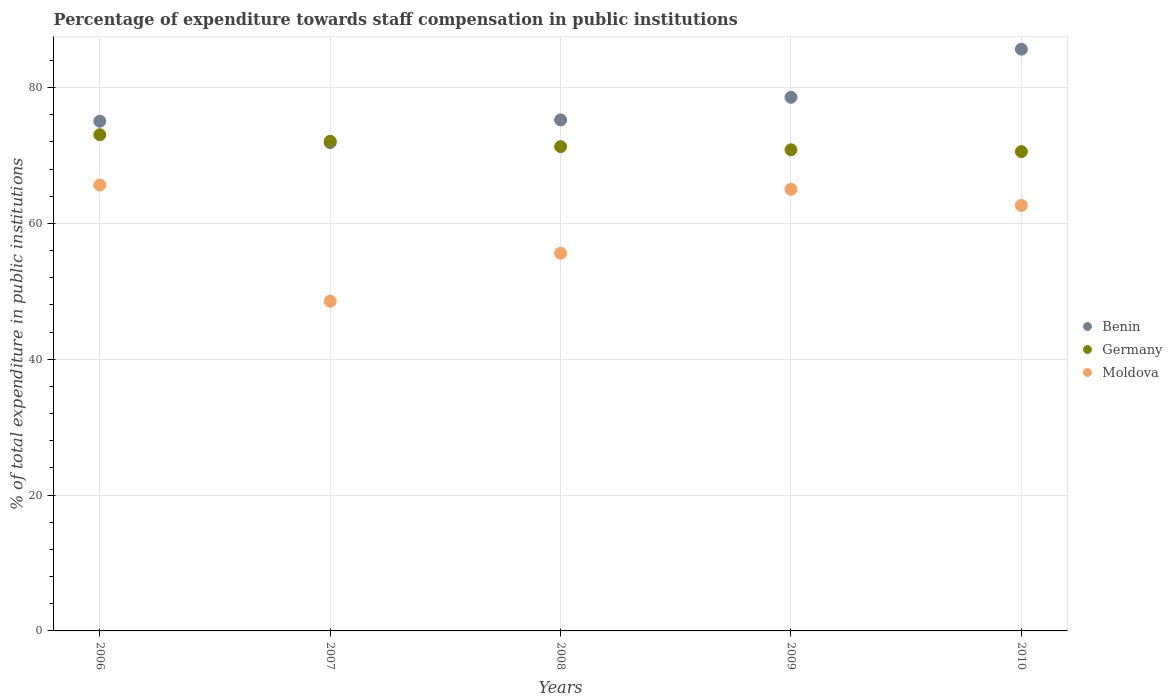How many different coloured dotlines are there?
Offer a terse response. 3. Is the number of dotlines equal to the number of legend labels?
Make the answer very short. Yes. What is the percentage of expenditure towards staff compensation in Moldova in 2006?
Your answer should be very brief. 65.65. Across all years, what is the maximum percentage of expenditure towards staff compensation in Germany?
Offer a very short reply. 73.06. Across all years, what is the minimum percentage of expenditure towards staff compensation in Germany?
Offer a very short reply. 70.57. In which year was the percentage of expenditure towards staff compensation in Germany maximum?
Make the answer very short. 2006. In which year was the percentage of expenditure towards staff compensation in Moldova minimum?
Offer a very short reply. 2007. What is the total percentage of expenditure towards staff compensation in Benin in the graph?
Your answer should be very brief. 386.41. What is the difference between the percentage of expenditure towards staff compensation in Benin in 2007 and that in 2010?
Provide a short and direct response. -13.76. What is the difference between the percentage of expenditure towards staff compensation in Germany in 2006 and the percentage of expenditure towards staff compensation in Benin in 2010?
Provide a short and direct response. -12.6. What is the average percentage of expenditure towards staff compensation in Germany per year?
Offer a terse response. 71.57. In the year 2008, what is the difference between the percentage of expenditure towards staff compensation in Benin and percentage of expenditure towards staff compensation in Germany?
Provide a succinct answer. 3.93. In how many years, is the percentage of expenditure towards staff compensation in Benin greater than 24 %?
Provide a succinct answer. 5. What is the ratio of the percentage of expenditure towards staff compensation in Benin in 2006 to that in 2008?
Provide a short and direct response. 1. What is the difference between the highest and the second highest percentage of expenditure towards staff compensation in Benin?
Your response must be concise. 7.08. What is the difference between the highest and the lowest percentage of expenditure towards staff compensation in Germany?
Your answer should be compact. 2.49. Is the sum of the percentage of expenditure towards staff compensation in Moldova in 2006 and 2010 greater than the maximum percentage of expenditure towards staff compensation in Benin across all years?
Offer a terse response. Yes. Is it the case that in every year, the sum of the percentage of expenditure towards staff compensation in Benin and percentage of expenditure towards staff compensation in Moldova  is greater than the percentage of expenditure towards staff compensation in Germany?
Provide a succinct answer. Yes. Is the percentage of expenditure towards staff compensation in Moldova strictly less than the percentage of expenditure towards staff compensation in Germany over the years?
Give a very brief answer. Yes. How many dotlines are there?
Ensure brevity in your answer.  3. What is the difference between two consecutive major ticks on the Y-axis?
Your answer should be compact. 20. Are the values on the major ticks of Y-axis written in scientific E-notation?
Your response must be concise. No. Does the graph contain any zero values?
Your response must be concise. No. Does the graph contain grids?
Give a very brief answer. Yes. How many legend labels are there?
Provide a short and direct response. 3. How are the legend labels stacked?
Your response must be concise. Vertical. What is the title of the graph?
Your answer should be very brief. Percentage of expenditure towards staff compensation in public institutions. Does "Kyrgyz Republic" appear as one of the legend labels in the graph?
Provide a short and direct response. No. What is the label or title of the X-axis?
Your response must be concise. Years. What is the label or title of the Y-axis?
Offer a very short reply. % of total expenditure in public institutions. What is the % of total expenditure in public institutions of Benin in 2006?
Offer a very short reply. 75.05. What is the % of total expenditure in public institutions in Germany in 2006?
Provide a succinct answer. 73.06. What is the % of total expenditure in public institutions of Moldova in 2006?
Provide a short and direct response. 65.65. What is the % of total expenditure in public institutions in Benin in 2007?
Your response must be concise. 71.89. What is the % of total expenditure in public institutions in Germany in 2007?
Provide a short and direct response. 72.1. What is the % of total expenditure in public institutions of Moldova in 2007?
Offer a terse response. 48.54. What is the % of total expenditure in public institutions in Benin in 2008?
Keep it short and to the point. 75.24. What is the % of total expenditure in public institutions of Germany in 2008?
Offer a terse response. 71.3. What is the % of total expenditure in public institutions in Moldova in 2008?
Ensure brevity in your answer.  55.61. What is the % of total expenditure in public institutions in Benin in 2009?
Your response must be concise. 78.57. What is the % of total expenditure in public institutions in Germany in 2009?
Your answer should be compact. 70.84. What is the % of total expenditure in public institutions in Moldova in 2009?
Your answer should be very brief. 65.02. What is the % of total expenditure in public institutions in Benin in 2010?
Provide a succinct answer. 85.65. What is the % of total expenditure in public institutions of Germany in 2010?
Provide a short and direct response. 70.57. What is the % of total expenditure in public institutions of Moldova in 2010?
Offer a very short reply. 62.65. Across all years, what is the maximum % of total expenditure in public institutions in Benin?
Provide a short and direct response. 85.65. Across all years, what is the maximum % of total expenditure in public institutions of Germany?
Your answer should be very brief. 73.06. Across all years, what is the maximum % of total expenditure in public institutions in Moldova?
Provide a succinct answer. 65.65. Across all years, what is the minimum % of total expenditure in public institutions of Benin?
Your response must be concise. 71.89. Across all years, what is the minimum % of total expenditure in public institutions of Germany?
Make the answer very short. 70.57. Across all years, what is the minimum % of total expenditure in public institutions of Moldova?
Ensure brevity in your answer.  48.54. What is the total % of total expenditure in public institutions of Benin in the graph?
Your answer should be compact. 386.41. What is the total % of total expenditure in public institutions of Germany in the graph?
Offer a very short reply. 357.87. What is the total % of total expenditure in public institutions in Moldova in the graph?
Your answer should be very brief. 297.47. What is the difference between the % of total expenditure in public institutions in Benin in 2006 and that in 2007?
Provide a short and direct response. 3.15. What is the difference between the % of total expenditure in public institutions in Germany in 2006 and that in 2007?
Your answer should be compact. 0.96. What is the difference between the % of total expenditure in public institutions of Moldova in 2006 and that in 2007?
Provide a short and direct response. 17.11. What is the difference between the % of total expenditure in public institutions of Benin in 2006 and that in 2008?
Ensure brevity in your answer.  -0.19. What is the difference between the % of total expenditure in public institutions of Germany in 2006 and that in 2008?
Your answer should be compact. 1.75. What is the difference between the % of total expenditure in public institutions in Moldova in 2006 and that in 2008?
Provide a succinct answer. 10.04. What is the difference between the % of total expenditure in public institutions of Benin in 2006 and that in 2009?
Offer a terse response. -3.52. What is the difference between the % of total expenditure in public institutions of Germany in 2006 and that in 2009?
Offer a terse response. 2.22. What is the difference between the % of total expenditure in public institutions in Moldova in 2006 and that in 2009?
Offer a very short reply. 0.63. What is the difference between the % of total expenditure in public institutions in Benin in 2006 and that in 2010?
Provide a short and direct response. -10.61. What is the difference between the % of total expenditure in public institutions of Germany in 2006 and that in 2010?
Your answer should be compact. 2.49. What is the difference between the % of total expenditure in public institutions in Moldova in 2006 and that in 2010?
Your answer should be very brief. 3. What is the difference between the % of total expenditure in public institutions in Benin in 2007 and that in 2008?
Keep it short and to the point. -3.34. What is the difference between the % of total expenditure in public institutions in Germany in 2007 and that in 2008?
Provide a succinct answer. 0.79. What is the difference between the % of total expenditure in public institutions in Moldova in 2007 and that in 2008?
Offer a terse response. -7.07. What is the difference between the % of total expenditure in public institutions of Benin in 2007 and that in 2009?
Your answer should be very brief. -6.68. What is the difference between the % of total expenditure in public institutions of Germany in 2007 and that in 2009?
Your answer should be very brief. 1.25. What is the difference between the % of total expenditure in public institutions in Moldova in 2007 and that in 2009?
Keep it short and to the point. -16.48. What is the difference between the % of total expenditure in public institutions of Benin in 2007 and that in 2010?
Provide a succinct answer. -13.76. What is the difference between the % of total expenditure in public institutions in Germany in 2007 and that in 2010?
Your response must be concise. 1.53. What is the difference between the % of total expenditure in public institutions in Moldova in 2007 and that in 2010?
Provide a succinct answer. -14.11. What is the difference between the % of total expenditure in public institutions of Benin in 2008 and that in 2009?
Provide a short and direct response. -3.34. What is the difference between the % of total expenditure in public institutions of Germany in 2008 and that in 2009?
Make the answer very short. 0.46. What is the difference between the % of total expenditure in public institutions of Moldova in 2008 and that in 2009?
Provide a succinct answer. -9.41. What is the difference between the % of total expenditure in public institutions of Benin in 2008 and that in 2010?
Your answer should be compact. -10.42. What is the difference between the % of total expenditure in public institutions in Germany in 2008 and that in 2010?
Ensure brevity in your answer.  0.73. What is the difference between the % of total expenditure in public institutions of Moldova in 2008 and that in 2010?
Ensure brevity in your answer.  -7.04. What is the difference between the % of total expenditure in public institutions in Benin in 2009 and that in 2010?
Ensure brevity in your answer.  -7.08. What is the difference between the % of total expenditure in public institutions in Germany in 2009 and that in 2010?
Give a very brief answer. 0.27. What is the difference between the % of total expenditure in public institutions in Moldova in 2009 and that in 2010?
Your answer should be very brief. 2.37. What is the difference between the % of total expenditure in public institutions of Benin in 2006 and the % of total expenditure in public institutions of Germany in 2007?
Give a very brief answer. 2.95. What is the difference between the % of total expenditure in public institutions in Benin in 2006 and the % of total expenditure in public institutions in Moldova in 2007?
Give a very brief answer. 26.51. What is the difference between the % of total expenditure in public institutions in Germany in 2006 and the % of total expenditure in public institutions in Moldova in 2007?
Your response must be concise. 24.52. What is the difference between the % of total expenditure in public institutions in Benin in 2006 and the % of total expenditure in public institutions in Germany in 2008?
Give a very brief answer. 3.74. What is the difference between the % of total expenditure in public institutions of Benin in 2006 and the % of total expenditure in public institutions of Moldova in 2008?
Make the answer very short. 19.44. What is the difference between the % of total expenditure in public institutions in Germany in 2006 and the % of total expenditure in public institutions in Moldova in 2008?
Your response must be concise. 17.45. What is the difference between the % of total expenditure in public institutions of Benin in 2006 and the % of total expenditure in public institutions of Germany in 2009?
Your answer should be compact. 4.21. What is the difference between the % of total expenditure in public institutions in Benin in 2006 and the % of total expenditure in public institutions in Moldova in 2009?
Ensure brevity in your answer.  10.03. What is the difference between the % of total expenditure in public institutions in Germany in 2006 and the % of total expenditure in public institutions in Moldova in 2009?
Your answer should be very brief. 8.04. What is the difference between the % of total expenditure in public institutions of Benin in 2006 and the % of total expenditure in public institutions of Germany in 2010?
Give a very brief answer. 4.48. What is the difference between the % of total expenditure in public institutions in Benin in 2006 and the % of total expenditure in public institutions in Moldova in 2010?
Ensure brevity in your answer.  12.4. What is the difference between the % of total expenditure in public institutions of Germany in 2006 and the % of total expenditure in public institutions of Moldova in 2010?
Keep it short and to the point. 10.41. What is the difference between the % of total expenditure in public institutions of Benin in 2007 and the % of total expenditure in public institutions of Germany in 2008?
Your response must be concise. 0.59. What is the difference between the % of total expenditure in public institutions of Benin in 2007 and the % of total expenditure in public institutions of Moldova in 2008?
Offer a very short reply. 16.28. What is the difference between the % of total expenditure in public institutions in Germany in 2007 and the % of total expenditure in public institutions in Moldova in 2008?
Ensure brevity in your answer.  16.49. What is the difference between the % of total expenditure in public institutions in Benin in 2007 and the % of total expenditure in public institutions in Germany in 2009?
Your answer should be very brief. 1.05. What is the difference between the % of total expenditure in public institutions in Benin in 2007 and the % of total expenditure in public institutions in Moldova in 2009?
Make the answer very short. 6.87. What is the difference between the % of total expenditure in public institutions in Germany in 2007 and the % of total expenditure in public institutions in Moldova in 2009?
Provide a succinct answer. 7.08. What is the difference between the % of total expenditure in public institutions of Benin in 2007 and the % of total expenditure in public institutions of Germany in 2010?
Offer a very short reply. 1.32. What is the difference between the % of total expenditure in public institutions in Benin in 2007 and the % of total expenditure in public institutions in Moldova in 2010?
Ensure brevity in your answer.  9.25. What is the difference between the % of total expenditure in public institutions in Germany in 2007 and the % of total expenditure in public institutions in Moldova in 2010?
Your answer should be very brief. 9.45. What is the difference between the % of total expenditure in public institutions of Benin in 2008 and the % of total expenditure in public institutions of Germany in 2009?
Offer a terse response. 4.39. What is the difference between the % of total expenditure in public institutions of Benin in 2008 and the % of total expenditure in public institutions of Moldova in 2009?
Keep it short and to the point. 10.21. What is the difference between the % of total expenditure in public institutions in Germany in 2008 and the % of total expenditure in public institutions in Moldova in 2009?
Offer a very short reply. 6.28. What is the difference between the % of total expenditure in public institutions of Benin in 2008 and the % of total expenditure in public institutions of Germany in 2010?
Provide a short and direct response. 4.67. What is the difference between the % of total expenditure in public institutions in Benin in 2008 and the % of total expenditure in public institutions in Moldova in 2010?
Provide a succinct answer. 12.59. What is the difference between the % of total expenditure in public institutions in Germany in 2008 and the % of total expenditure in public institutions in Moldova in 2010?
Ensure brevity in your answer.  8.66. What is the difference between the % of total expenditure in public institutions in Benin in 2009 and the % of total expenditure in public institutions in Germany in 2010?
Make the answer very short. 8. What is the difference between the % of total expenditure in public institutions in Benin in 2009 and the % of total expenditure in public institutions in Moldova in 2010?
Your response must be concise. 15.93. What is the difference between the % of total expenditure in public institutions in Germany in 2009 and the % of total expenditure in public institutions in Moldova in 2010?
Your answer should be compact. 8.2. What is the average % of total expenditure in public institutions in Benin per year?
Your answer should be very brief. 77.28. What is the average % of total expenditure in public institutions of Germany per year?
Provide a short and direct response. 71.57. What is the average % of total expenditure in public institutions of Moldova per year?
Your answer should be compact. 59.49. In the year 2006, what is the difference between the % of total expenditure in public institutions in Benin and % of total expenditure in public institutions in Germany?
Give a very brief answer. 1.99. In the year 2006, what is the difference between the % of total expenditure in public institutions of Benin and % of total expenditure in public institutions of Moldova?
Give a very brief answer. 9.4. In the year 2006, what is the difference between the % of total expenditure in public institutions in Germany and % of total expenditure in public institutions in Moldova?
Provide a succinct answer. 7.41. In the year 2007, what is the difference between the % of total expenditure in public institutions in Benin and % of total expenditure in public institutions in Germany?
Give a very brief answer. -0.2. In the year 2007, what is the difference between the % of total expenditure in public institutions in Benin and % of total expenditure in public institutions in Moldova?
Provide a short and direct response. 23.35. In the year 2007, what is the difference between the % of total expenditure in public institutions of Germany and % of total expenditure in public institutions of Moldova?
Provide a short and direct response. 23.56. In the year 2008, what is the difference between the % of total expenditure in public institutions of Benin and % of total expenditure in public institutions of Germany?
Keep it short and to the point. 3.93. In the year 2008, what is the difference between the % of total expenditure in public institutions in Benin and % of total expenditure in public institutions in Moldova?
Your answer should be compact. 19.63. In the year 2008, what is the difference between the % of total expenditure in public institutions in Germany and % of total expenditure in public institutions in Moldova?
Offer a terse response. 15.7. In the year 2009, what is the difference between the % of total expenditure in public institutions in Benin and % of total expenditure in public institutions in Germany?
Keep it short and to the point. 7.73. In the year 2009, what is the difference between the % of total expenditure in public institutions of Benin and % of total expenditure in public institutions of Moldova?
Provide a succinct answer. 13.55. In the year 2009, what is the difference between the % of total expenditure in public institutions in Germany and % of total expenditure in public institutions in Moldova?
Ensure brevity in your answer.  5.82. In the year 2010, what is the difference between the % of total expenditure in public institutions in Benin and % of total expenditure in public institutions in Germany?
Provide a succinct answer. 15.08. In the year 2010, what is the difference between the % of total expenditure in public institutions of Benin and % of total expenditure in public institutions of Moldova?
Ensure brevity in your answer.  23.01. In the year 2010, what is the difference between the % of total expenditure in public institutions in Germany and % of total expenditure in public institutions in Moldova?
Your answer should be very brief. 7.92. What is the ratio of the % of total expenditure in public institutions of Benin in 2006 to that in 2007?
Ensure brevity in your answer.  1.04. What is the ratio of the % of total expenditure in public institutions in Germany in 2006 to that in 2007?
Your answer should be very brief. 1.01. What is the ratio of the % of total expenditure in public institutions in Moldova in 2006 to that in 2007?
Your response must be concise. 1.35. What is the ratio of the % of total expenditure in public institutions in Benin in 2006 to that in 2008?
Give a very brief answer. 1. What is the ratio of the % of total expenditure in public institutions of Germany in 2006 to that in 2008?
Offer a terse response. 1.02. What is the ratio of the % of total expenditure in public institutions of Moldova in 2006 to that in 2008?
Provide a succinct answer. 1.18. What is the ratio of the % of total expenditure in public institutions of Benin in 2006 to that in 2009?
Offer a terse response. 0.96. What is the ratio of the % of total expenditure in public institutions of Germany in 2006 to that in 2009?
Provide a short and direct response. 1.03. What is the ratio of the % of total expenditure in public institutions in Moldova in 2006 to that in 2009?
Your answer should be very brief. 1.01. What is the ratio of the % of total expenditure in public institutions of Benin in 2006 to that in 2010?
Provide a short and direct response. 0.88. What is the ratio of the % of total expenditure in public institutions in Germany in 2006 to that in 2010?
Provide a short and direct response. 1.04. What is the ratio of the % of total expenditure in public institutions in Moldova in 2006 to that in 2010?
Provide a succinct answer. 1.05. What is the ratio of the % of total expenditure in public institutions of Benin in 2007 to that in 2008?
Offer a terse response. 0.96. What is the ratio of the % of total expenditure in public institutions of Germany in 2007 to that in 2008?
Provide a short and direct response. 1.01. What is the ratio of the % of total expenditure in public institutions of Moldova in 2007 to that in 2008?
Ensure brevity in your answer.  0.87. What is the ratio of the % of total expenditure in public institutions in Benin in 2007 to that in 2009?
Your response must be concise. 0.92. What is the ratio of the % of total expenditure in public institutions in Germany in 2007 to that in 2009?
Offer a very short reply. 1.02. What is the ratio of the % of total expenditure in public institutions in Moldova in 2007 to that in 2009?
Make the answer very short. 0.75. What is the ratio of the % of total expenditure in public institutions in Benin in 2007 to that in 2010?
Provide a short and direct response. 0.84. What is the ratio of the % of total expenditure in public institutions of Germany in 2007 to that in 2010?
Provide a succinct answer. 1.02. What is the ratio of the % of total expenditure in public institutions of Moldova in 2007 to that in 2010?
Make the answer very short. 0.77. What is the ratio of the % of total expenditure in public institutions of Benin in 2008 to that in 2009?
Provide a short and direct response. 0.96. What is the ratio of the % of total expenditure in public institutions of Moldova in 2008 to that in 2009?
Provide a succinct answer. 0.86. What is the ratio of the % of total expenditure in public institutions of Benin in 2008 to that in 2010?
Your answer should be compact. 0.88. What is the ratio of the % of total expenditure in public institutions in Germany in 2008 to that in 2010?
Provide a succinct answer. 1.01. What is the ratio of the % of total expenditure in public institutions of Moldova in 2008 to that in 2010?
Give a very brief answer. 0.89. What is the ratio of the % of total expenditure in public institutions in Benin in 2009 to that in 2010?
Provide a succinct answer. 0.92. What is the ratio of the % of total expenditure in public institutions in Germany in 2009 to that in 2010?
Your answer should be compact. 1. What is the ratio of the % of total expenditure in public institutions of Moldova in 2009 to that in 2010?
Make the answer very short. 1.04. What is the difference between the highest and the second highest % of total expenditure in public institutions in Benin?
Provide a short and direct response. 7.08. What is the difference between the highest and the second highest % of total expenditure in public institutions in Germany?
Make the answer very short. 0.96. What is the difference between the highest and the second highest % of total expenditure in public institutions in Moldova?
Offer a terse response. 0.63. What is the difference between the highest and the lowest % of total expenditure in public institutions in Benin?
Your answer should be compact. 13.76. What is the difference between the highest and the lowest % of total expenditure in public institutions of Germany?
Keep it short and to the point. 2.49. What is the difference between the highest and the lowest % of total expenditure in public institutions in Moldova?
Keep it short and to the point. 17.11. 